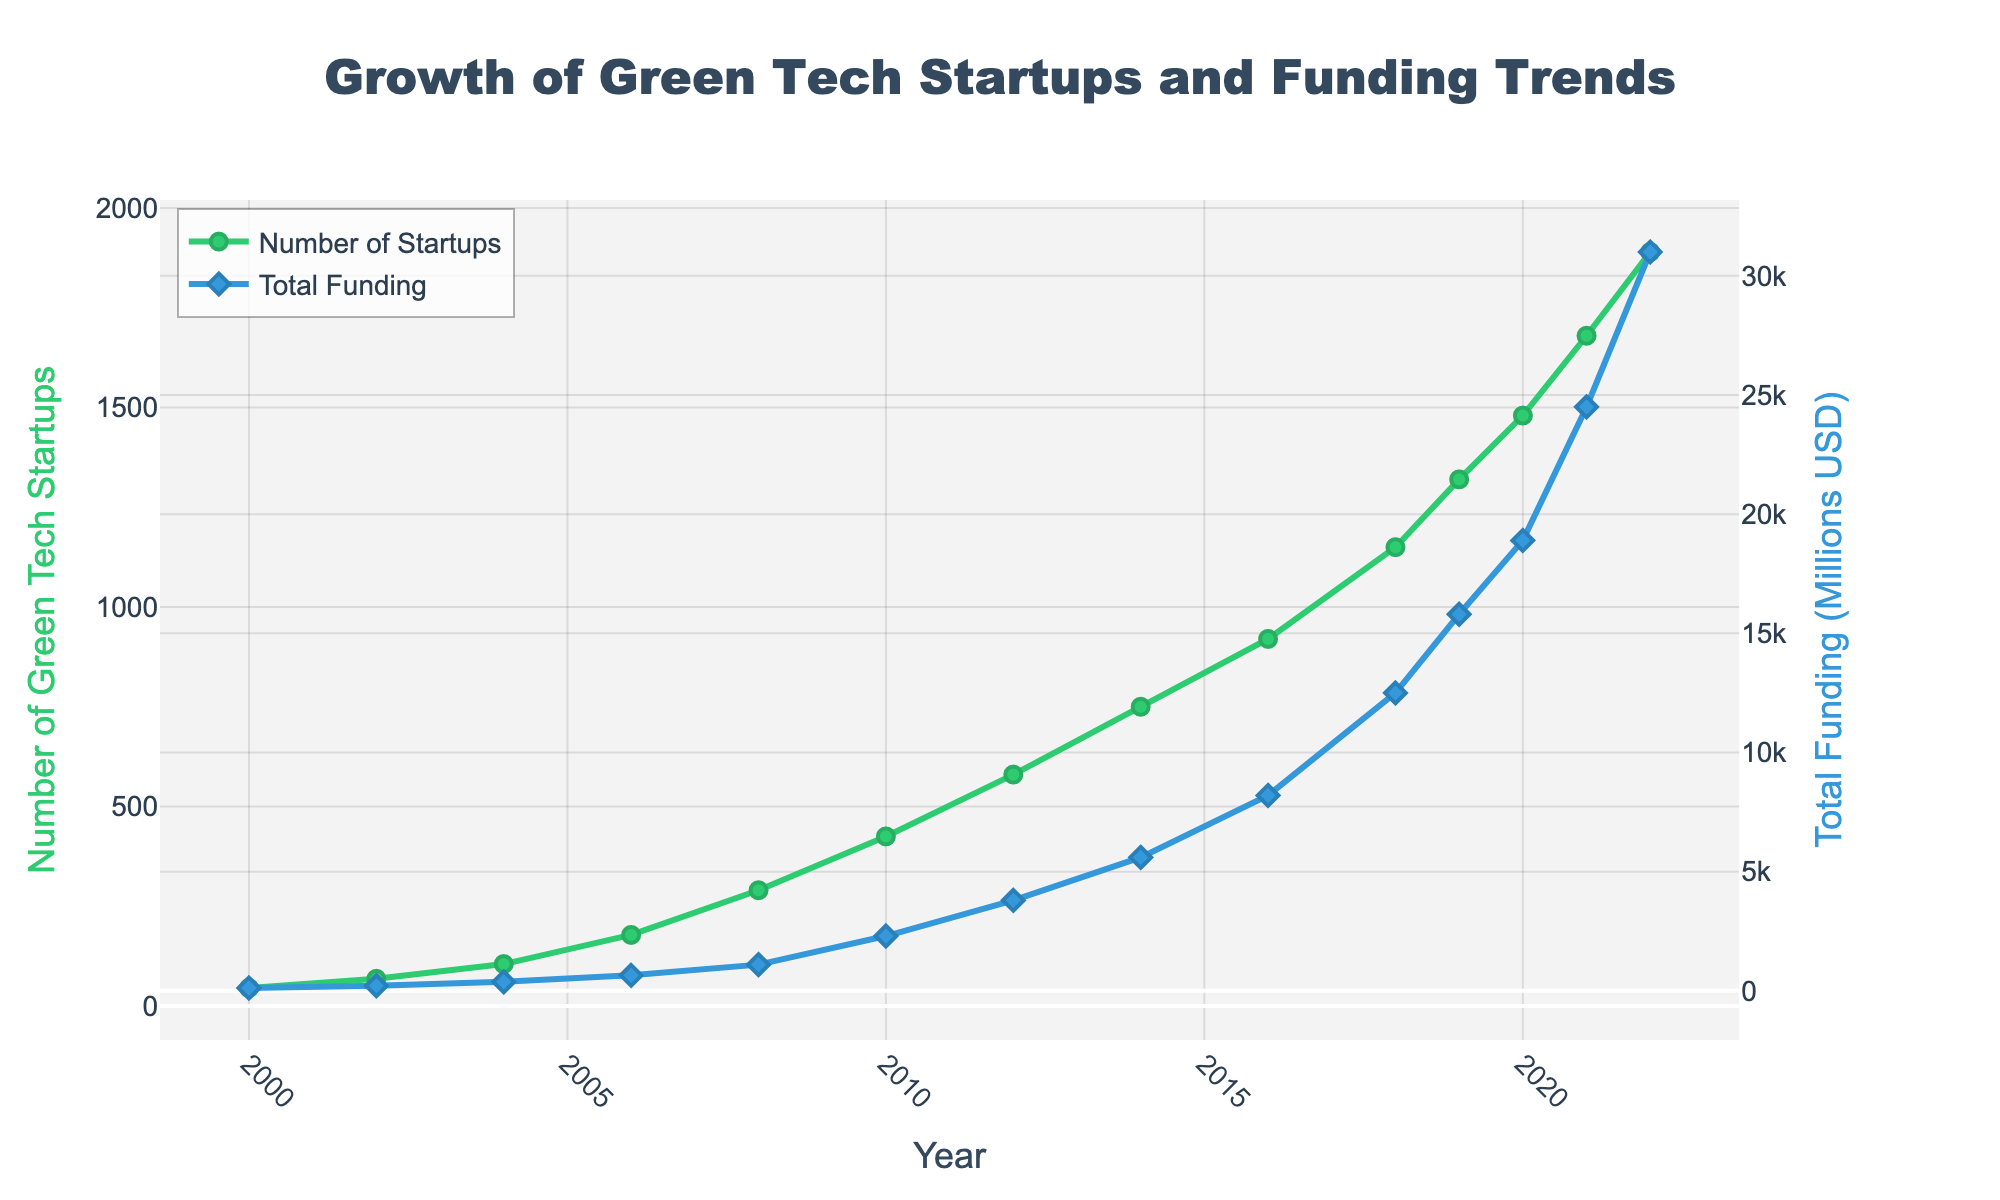What is the trend in the number of green tech startups from 2000 to 2022? The number of green tech startups shows a clear increasing trend over time, starting from 45 in 2000 and rising to 1890 in 2022.
Answer: Increasing Which year had the highest total funding for green tech startups, and what was the amount? The peak in total funding occurred in 2022, with a total amount of 31,000 million USD.
Answer: 2022, 31,000 million USD How does the rate of growth in the number of startups between 2010 and 2014 compare to the rate between 2014 and 2018? From 2010 to 2014, the number of startups increased from 425 to 750, a difference of 325 over 4 years. Between 2014 and 2018, the number increased from 750 to 1150, a difference of 400 over 4 years. The rate from 2014 to 2018 is higher.
Answer: 2014 to 2018 is higher What is the average total funding in millions USD from 2008 to 2022? Find the total funding amounts from 2008 to 2022, add them up: 1100 + 2300 + 3800 + 5600 + 8200 + 12500 + 15800 + 18900 + 24500 + 31000 = 112700. There are 10 data points. The average is 112700 / 10 = 11270 million USD.
Answer: 11270 million USD What color represents the funding trend on the plot? The total funding trend is represented by a blue line in the plot.
Answer: Blue In which year did the number of startups surpass 1000? The number of startups surpassed 1000 in 2018.
Answer: 2018 Compare the total funding between the years 2006 and 2010. Which year had higher funding and by how much? The total funding in 2006 was 650 million USD, and in 2010 it was 2300 million USD. 2010 had higher funding by 2300 - 650 = 1650 million USD.
Answer: 2010, by 1650 million USD How does the increase in total funding between 2019 and 2021 compare to the increase between 2021 and 2022? From 2019 to 2021, the funding increased from 15800 to 24500 million USD, a difference of 8700 million USD. From 2021 to 2022, the funding increased from 24500 to 31000 million USD, a difference of 6500 million USD. The increase from 2019 to 2021 is higher.
Answer: 2019 to 2021 is higher 